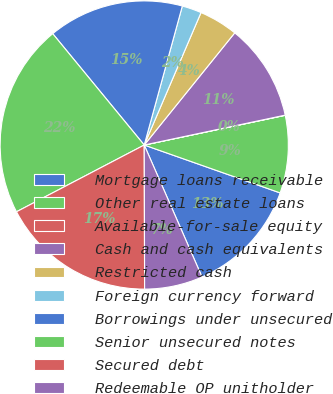Convert chart. <chart><loc_0><loc_0><loc_500><loc_500><pie_chart><fcel>Mortgage loans receivable<fcel>Other real estate loans<fcel>Available-for-sale equity<fcel>Cash and cash equivalents<fcel>Restricted cash<fcel>Foreign currency forward<fcel>Borrowings under unsecured<fcel>Senior unsecured notes<fcel>Secured debt<fcel>Redeemable OP unitholder<nl><fcel>13.04%<fcel>8.7%<fcel>0.02%<fcel>10.87%<fcel>4.36%<fcel>2.19%<fcel>15.21%<fcel>21.72%<fcel>17.38%<fcel>6.53%<nl></chart> 